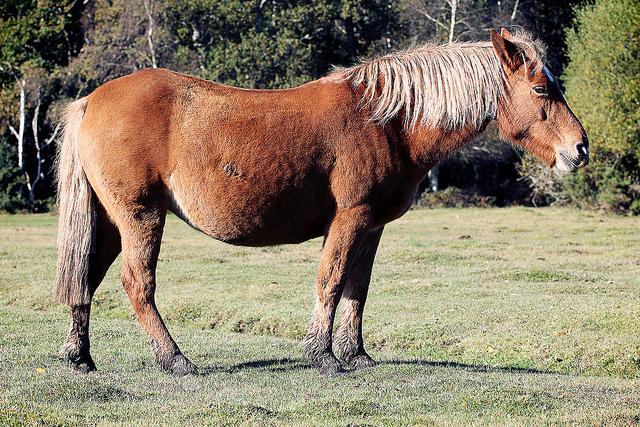Does this animal appear old or young?
Quick response, please. Old. Is this horse wearing a saddle?
Be succinct. No. What color is the horse?
Give a very brief answer. Brown. How many horses are in this image?
Keep it brief. 1. 